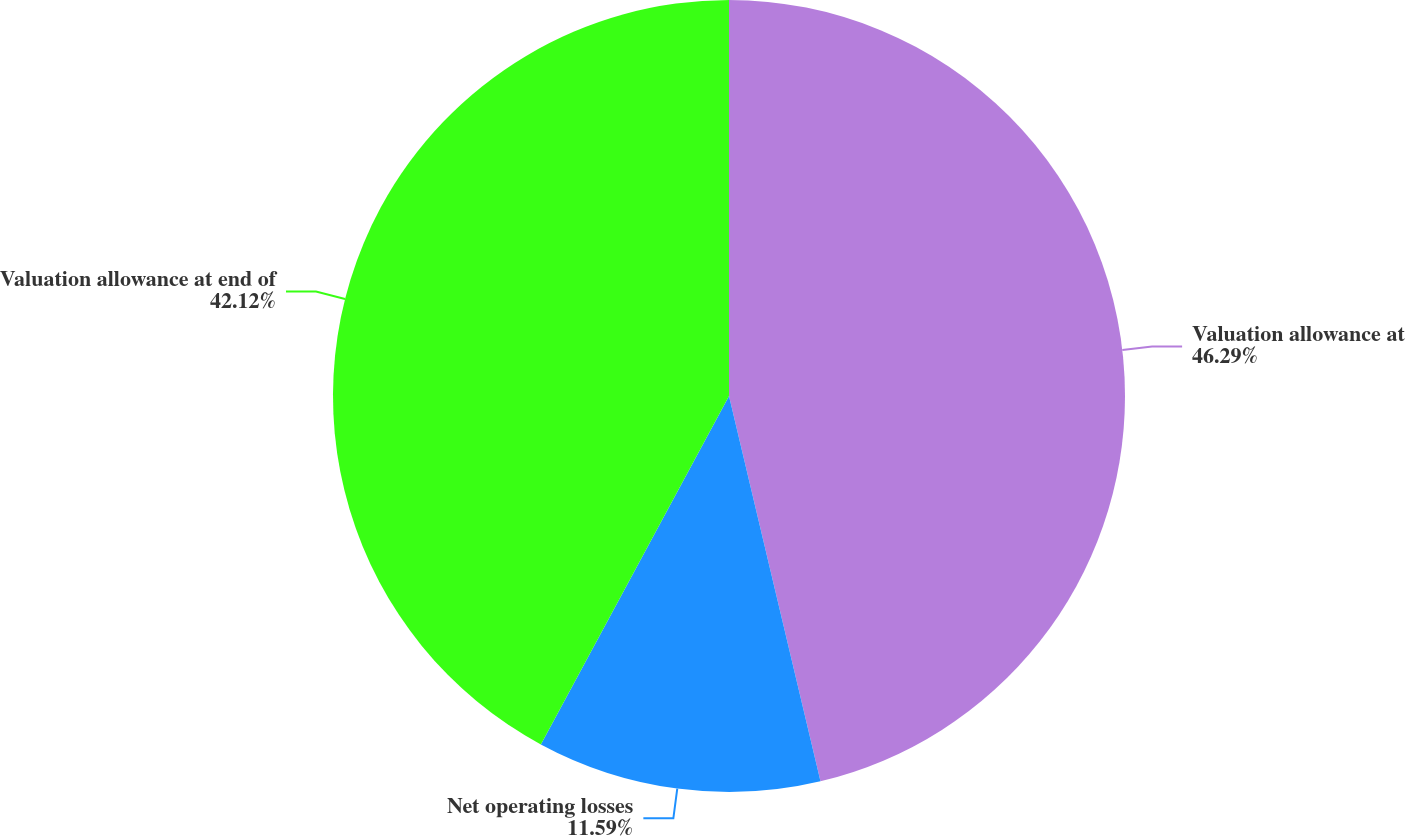Convert chart to OTSL. <chart><loc_0><loc_0><loc_500><loc_500><pie_chart><fcel>Valuation allowance at<fcel>Net operating losses<fcel>Valuation allowance at end of<nl><fcel>46.29%<fcel>11.59%<fcel>42.12%<nl></chart> 